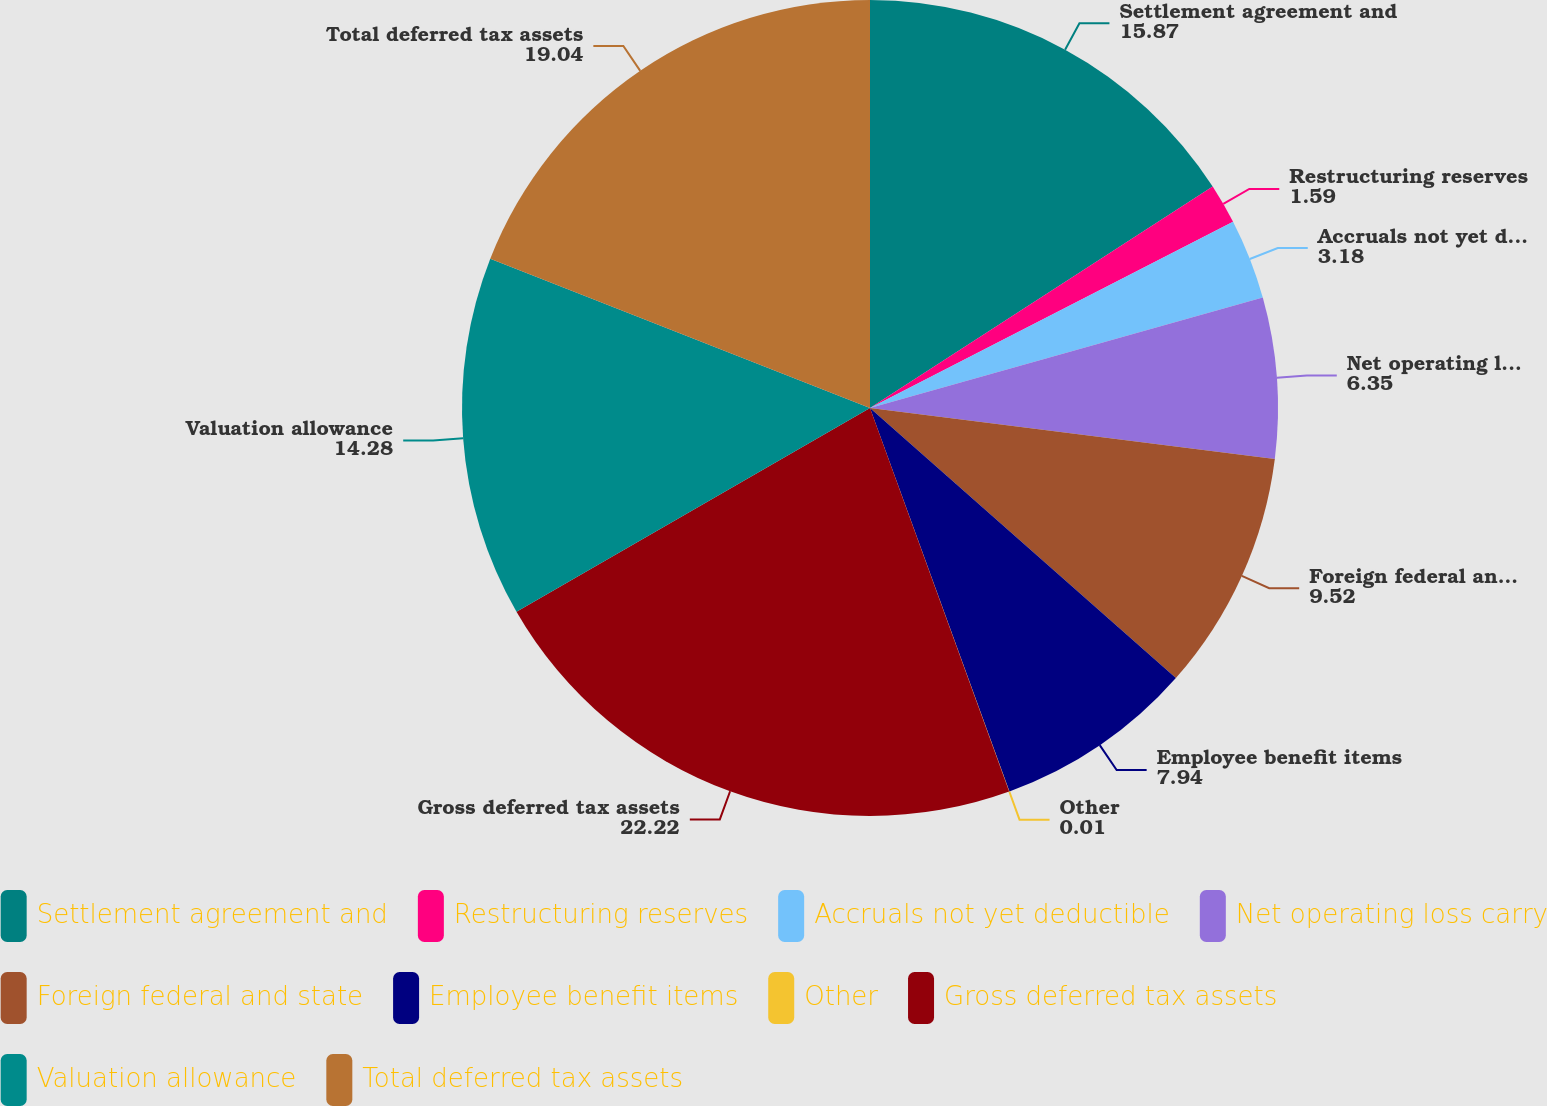Convert chart. <chart><loc_0><loc_0><loc_500><loc_500><pie_chart><fcel>Settlement agreement and<fcel>Restructuring reserves<fcel>Accruals not yet deductible<fcel>Net operating loss carry<fcel>Foreign federal and state<fcel>Employee benefit items<fcel>Other<fcel>Gross deferred tax assets<fcel>Valuation allowance<fcel>Total deferred tax assets<nl><fcel>15.87%<fcel>1.59%<fcel>3.18%<fcel>6.35%<fcel>9.52%<fcel>7.94%<fcel>0.01%<fcel>22.22%<fcel>14.28%<fcel>19.04%<nl></chart> 